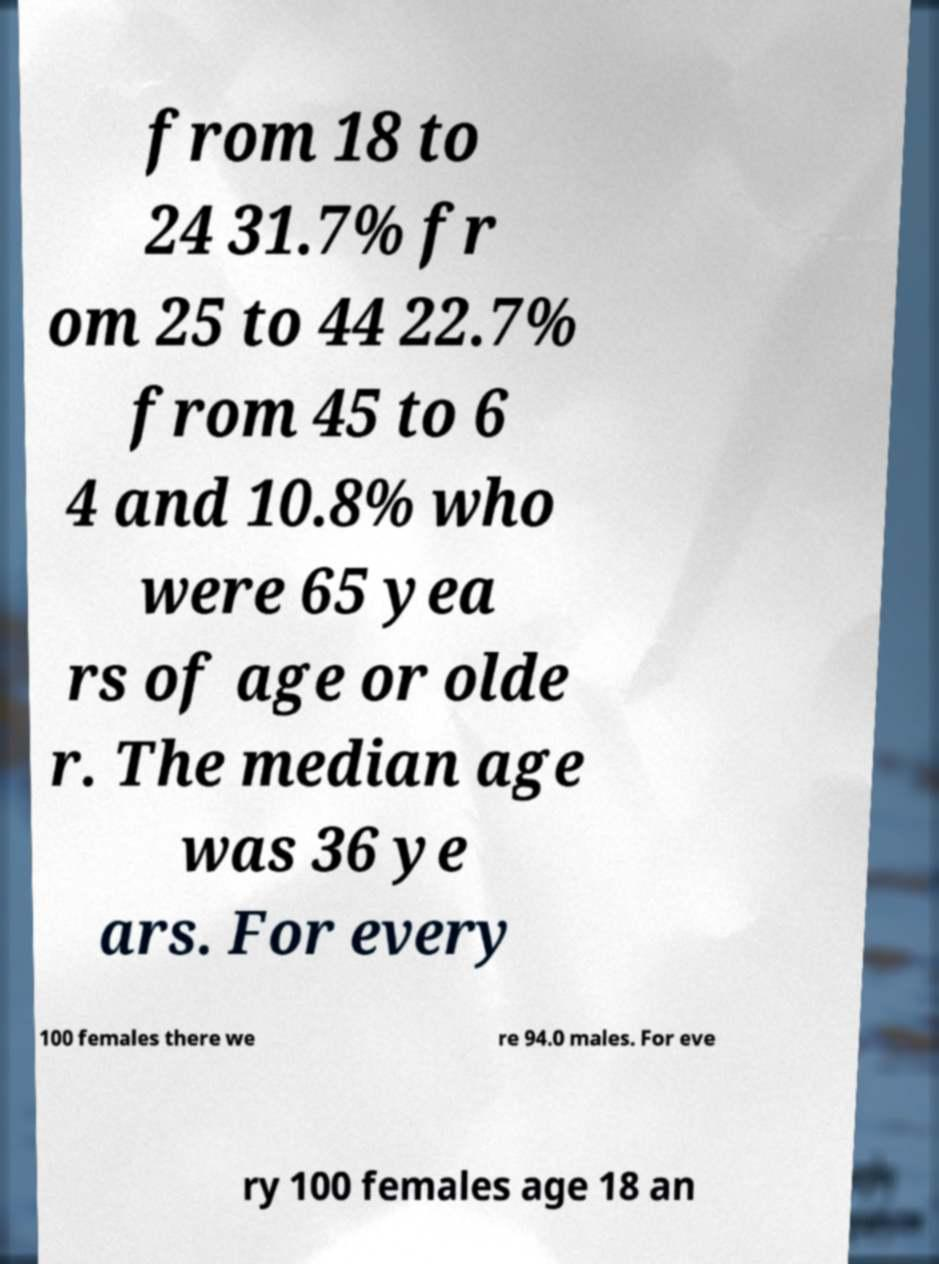Please read and relay the text visible in this image. What does it say? from 18 to 24 31.7% fr om 25 to 44 22.7% from 45 to 6 4 and 10.8% who were 65 yea rs of age or olde r. The median age was 36 ye ars. For every 100 females there we re 94.0 males. For eve ry 100 females age 18 an 